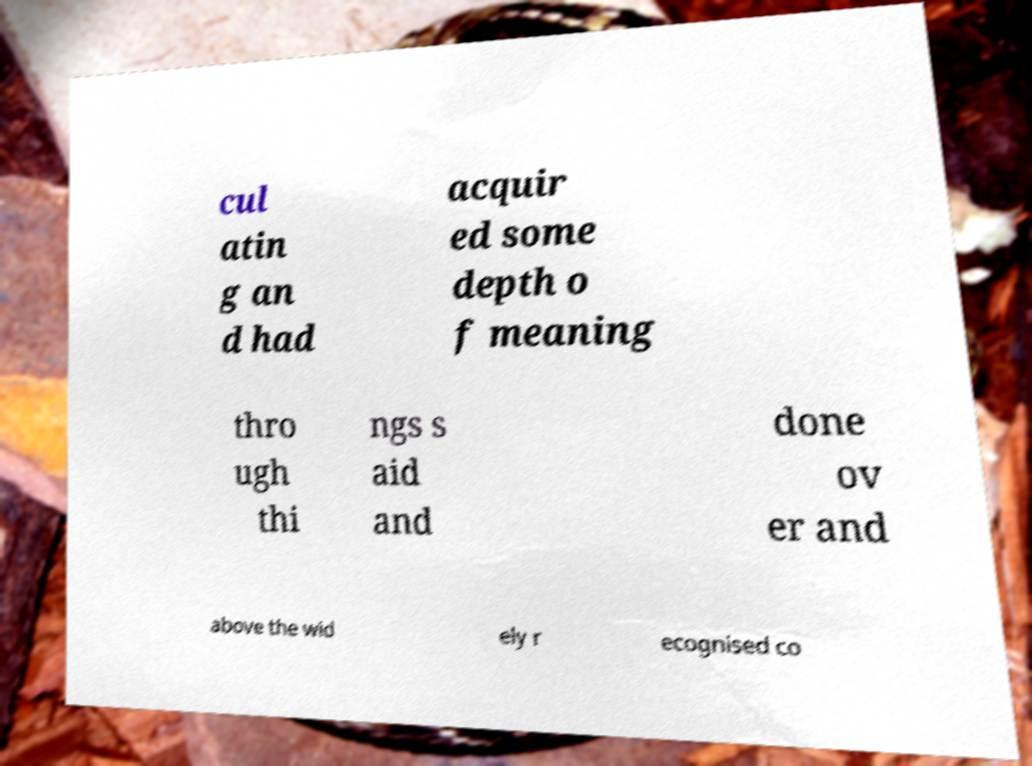Can you accurately transcribe the text from the provided image for me? cul atin g an d had acquir ed some depth o f meaning thro ugh thi ngs s aid and done ov er and above the wid ely r ecognised co 